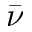<formula> <loc_0><loc_0><loc_500><loc_500>\bar { \nu }</formula> 